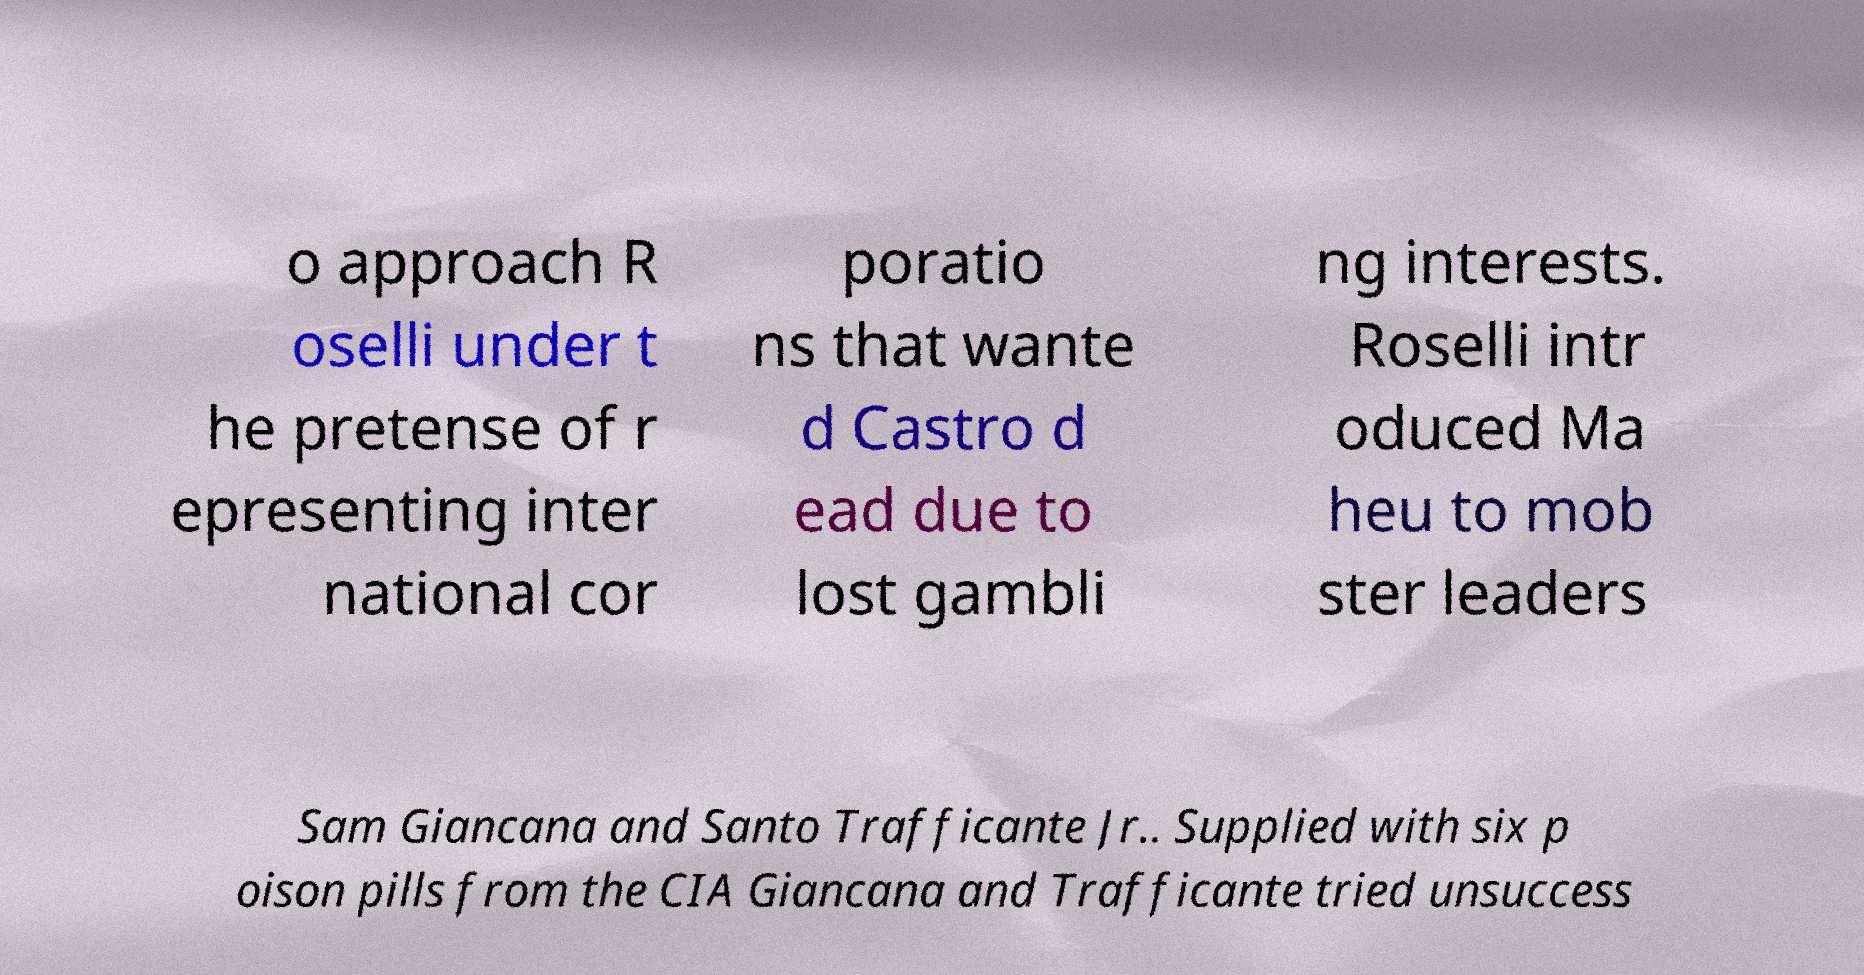There's text embedded in this image that I need extracted. Can you transcribe it verbatim? o approach R oselli under t he pretense of r epresenting inter national cor poratio ns that wante d Castro d ead due to lost gambli ng interests. Roselli intr oduced Ma heu to mob ster leaders Sam Giancana and Santo Trafficante Jr.. Supplied with six p oison pills from the CIA Giancana and Trafficante tried unsuccess 